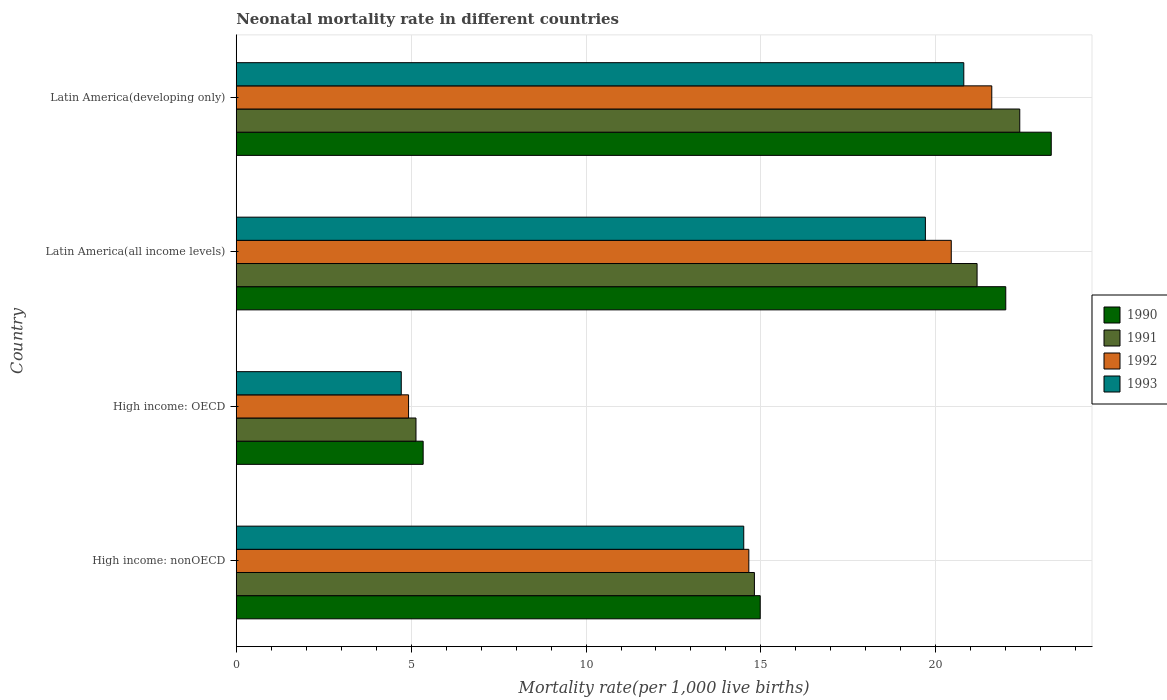How many bars are there on the 4th tick from the top?
Offer a terse response. 4. What is the label of the 3rd group of bars from the top?
Your answer should be compact. High income: OECD. What is the neonatal mortality rate in 1992 in Latin America(developing only)?
Provide a short and direct response. 21.6. Across all countries, what is the maximum neonatal mortality rate in 1992?
Provide a short and direct response. 21.6. Across all countries, what is the minimum neonatal mortality rate in 1992?
Provide a succinct answer. 4.93. In which country was the neonatal mortality rate in 1993 maximum?
Provide a short and direct response. Latin America(developing only). In which country was the neonatal mortality rate in 1991 minimum?
Make the answer very short. High income: OECD. What is the total neonatal mortality rate in 1992 in the graph?
Your answer should be very brief. 61.62. What is the difference between the neonatal mortality rate in 1993 in High income: nonOECD and that in Latin America(developing only)?
Your answer should be compact. -6.29. What is the difference between the neonatal mortality rate in 1992 in Latin America(all income levels) and the neonatal mortality rate in 1990 in Latin America(developing only)?
Offer a terse response. -2.86. What is the average neonatal mortality rate in 1992 per country?
Ensure brevity in your answer.  15.41. What is the difference between the neonatal mortality rate in 1993 and neonatal mortality rate in 1991 in High income: OECD?
Offer a very short reply. -0.42. What is the ratio of the neonatal mortality rate in 1991 in High income: nonOECD to that in Latin America(all income levels)?
Your answer should be compact. 0.7. Is the neonatal mortality rate in 1993 in High income: OECD less than that in High income: nonOECD?
Offer a terse response. Yes. Is the difference between the neonatal mortality rate in 1993 in High income: OECD and Latin America(developing only) greater than the difference between the neonatal mortality rate in 1991 in High income: OECD and Latin America(developing only)?
Provide a short and direct response. Yes. What is the difference between the highest and the second highest neonatal mortality rate in 1990?
Your response must be concise. 1.3. What is the difference between the highest and the lowest neonatal mortality rate in 1990?
Your answer should be compact. 17.96. In how many countries, is the neonatal mortality rate in 1990 greater than the average neonatal mortality rate in 1990 taken over all countries?
Provide a short and direct response. 2. Is the sum of the neonatal mortality rate in 1991 in High income: OECD and High income: nonOECD greater than the maximum neonatal mortality rate in 1992 across all countries?
Keep it short and to the point. No. How many bars are there?
Your response must be concise. 16. Are all the bars in the graph horizontal?
Offer a terse response. Yes. What is the difference between two consecutive major ticks on the X-axis?
Offer a terse response. 5. Are the values on the major ticks of X-axis written in scientific E-notation?
Your answer should be very brief. No. Does the graph contain any zero values?
Your answer should be very brief. No. Does the graph contain grids?
Your answer should be very brief. Yes. How are the legend labels stacked?
Give a very brief answer. Vertical. What is the title of the graph?
Offer a very short reply. Neonatal mortality rate in different countries. What is the label or title of the X-axis?
Provide a succinct answer. Mortality rate(per 1,0 live births). What is the Mortality rate(per 1,000 live births) of 1990 in High income: nonOECD?
Make the answer very short. 14.98. What is the Mortality rate(per 1,000 live births) in 1991 in High income: nonOECD?
Provide a short and direct response. 14.81. What is the Mortality rate(per 1,000 live births) in 1992 in High income: nonOECD?
Make the answer very short. 14.65. What is the Mortality rate(per 1,000 live births) in 1993 in High income: nonOECD?
Offer a terse response. 14.51. What is the Mortality rate(per 1,000 live births) in 1990 in High income: OECD?
Provide a succinct answer. 5.34. What is the Mortality rate(per 1,000 live births) of 1991 in High income: OECD?
Your answer should be compact. 5.14. What is the Mortality rate(per 1,000 live births) of 1992 in High income: OECD?
Your response must be concise. 4.93. What is the Mortality rate(per 1,000 live births) in 1993 in High income: OECD?
Make the answer very short. 4.72. What is the Mortality rate(per 1,000 live births) in 1990 in Latin America(all income levels)?
Make the answer very short. 22. What is the Mortality rate(per 1,000 live births) in 1991 in Latin America(all income levels)?
Offer a very short reply. 21.18. What is the Mortality rate(per 1,000 live births) of 1992 in Latin America(all income levels)?
Keep it short and to the point. 20.44. What is the Mortality rate(per 1,000 live births) in 1993 in Latin America(all income levels)?
Your answer should be compact. 19.7. What is the Mortality rate(per 1,000 live births) of 1990 in Latin America(developing only)?
Provide a succinct answer. 23.3. What is the Mortality rate(per 1,000 live births) in 1991 in Latin America(developing only)?
Your answer should be very brief. 22.4. What is the Mortality rate(per 1,000 live births) in 1992 in Latin America(developing only)?
Provide a succinct answer. 21.6. What is the Mortality rate(per 1,000 live births) of 1993 in Latin America(developing only)?
Provide a succinct answer. 20.8. Across all countries, what is the maximum Mortality rate(per 1,000 live births) of 1990?
Ensure brevity in your answer.  23.3. Across all countries, what is the maximum Mortality rate(per 1,000 live births) of 1991?
Your answer should be very brief. 22.4. Across all countries, what is the maximum Mortality rate(per 1,000 live births) in 1992?
Your response must be concise. 21.6. Across all countries, what is the maximum Mortality rate(per 1,000 live births) in 1993?
Provide a succinct answer. 20.8. Across all countries, what is the minimum Mortality rate(per 1,000 live births) in 1990?
Offer a very short reply. 5.34. Across all countries, what is the minimum Mortality rate(per 1,000 live births) of 1991?
Offer a very short reply. 5.14. Across all countries, what is the minimum Mortality rate(per 1,000 live births) in 1992?
Offer a very short reply. 4.93. Across all countries, what is the minimum Mortality rate(per 1,000 live births) in 1993?
Keep it short and to the point. 4.72. What is the total Mortality rate(per 1,000 live births) in 1990 in the graph?
Make the answer very short. 65.62. What is the total Mortality rate(per 1,000 live births) in 1991 in the graph?
Make the answer very short. 63.53. What is the total Mortality rate(per 1,000 live births) in 1992 in the graph?
Offer a very short reply. 61.62. What is the total Mortality rate(per 1,000 live births) of 1993 in the graph?
Your answer should be compact. 59.73. What is the difference between the Mortality rate(per 1,000 live births) of 1990 in High income: nonOECD and that in High income: OECD?
Your response must be concise. 9.64. What is the difference between the Mortality rate(per 1,000 live births) in 1991 in High income: nonOECD and that in High income: OECD?
Ensure brevity in your answer.  9.68. What is the difference between the Mortality rate(per 1,000 live births) of 1992 in High income: nonOECD and that in High income: OECD?
Give a very brief answer. 9.73. What is the difference between the Mortality rate(per 1,000 live births) of 1993 in High income: nonOECD and that in High income: OECD?
Make the answer very short. 9.79. What is the difference between the Mortality rate(per 1,000 live births) in 1990 in High income: nonOECD and that in Latin America(all income levels)?
Provide a succinct answer. -7.02. What is the difference between the Mortality rate(per 1,000 live births) in 1991 in High income: nonOECD and that in Latin America(all income levels)?
Make the answer very short. -6.37. What is the difference between the Mortality rate(per 1,000 live births) of 1992 in High income: nonOECD and that in Latin America(all income levels)?
Make the answer very short. -5.79. What is the difference between the Mortality rate(per 1,000 live births) in 1993 in High income: nonOECD and that in Latin America(all income levels)?
Offer a very short reply. -5.19. What is the difference between the Mortality rate(per 1,000 live births) in 1990 in High income: nonOECD and that in Latin America(developing only)?
Your answer should be compact. -8.32. What is the difference between the Mortality rate(per 1,000 live births) of 1991 in High income: nonOECD and that in Latin America(developing only)?
Make the answer very short. -7.59. What is the difference between the Mortality rate(per 1,000 live births) of 1992 in High income: nonOECD and that in Latin America(developing only)?
Offer a terse response. -6.95. What is the difference between the Mortality rate(per 1,000 live births) of 1993 in High income: nonOECD and that in Latin America(developing only)?
Your answer should be compact. -6.29. What is the difference between the Mortality rate(per 1,000 live births) of 1990 in High income: OECD and that in Latin America(all income levels)?
Provide a succinct answer. -16.66. What is the difference between the Mortality rate(per 1,000 live births) in 1991 in High income: OECD and that in Latin America(all income levels)?
Provide a short and direct response. -16.04. What is the difference between the Mortality rate(per 1,000 live births) in 1992 in High income: OECD and that in Latin America(all income levels)?
Ensure brevity in your answer.  -15.52. What is the difference between the Mortality rate(per 1,000 live births) of 1993 in High income: OECD and that in Latin America(all income levels)?
Give a very brief answer. -14.98. What is the difference between the Mortality rate(per 1,000 live births) of 1990 in High income: OECD and that in Latin America(developing only)?
Provide a succinct answer. -17.96. What is the difference between the Mortality rate(per 1,000 live births) of 1991 in High income: OECD and that in Latin America(developing only)?
Ensure brevity in your answer.  -17.26. What is the difference between the Mortality rate(per 1,000 live births) of 1992 in High income: OECD and that in Latin America(developing only)?
Ensure brevity in your answer.  -16.67. What is the difference between the Mortality rate(per 1,000 live births) of 1993 in High income: OECD and that in Latin America(developing only)?
Provide a short and direct response. -16.08. What is the difference between the Mortality rate(per 1,000 live births) in 1990 in Latin America(all income levels) and that in Latin America(developing only)?
Provide a succinct answer. -1.3. What is the difference between the Mortality rate(per 1,000 live births) of 1991 in Latin America(all income levels) and that in Latin America(developing only)?
Keep it short and to the point. -1.22. What is the difference between the Mortality rate(per 1,000 live births) of 1992 in Latin America(all income levels) and that in Latin America(developing only)?
Make the answer very short. -1.16. What is the difference between the Mortality rate(per 1,000 live births) of 1993 in Latin America(all income levels) and that in Latin America(developing only)?
Make the answer very short. -1.1. What is the difference between the Mortality rate(per 1,000 live births) of 1990 in High income: nonOECD and the Mortality rate(per 1,000 live births) of 1991 in High income: OECD?
Give a very brief answer. 9.84. What is the difference between the Mortality rate(per 1,000 live births) in 1990 in High income: nonOECD and the Mortality rate(per 1,000 live births) in 1992 in High income: OECD?
Your response must be concise. 10.05. What is the difference between the Mortality rate(per 1,000 live births) in 1990 in High income: nonOECD and the Mortality rate(per 1,000 live births) in 1993 in High income: OECD?
Make the answer very short. 10.26. What is the difference between the Mortality rate(per 1,000 live births) of 1991 in High income: nonOECD and the Mortality rate(per 1,000 live births) of 1992 in High income: OECD?
Provide a short and direct response. 9.89. What is the difference between the Mortality rate(per 1,000 live births) in 1991 in High income: nonOECD and the Mortality rate(per 1,000 live births) in 1993 in High income: OECD?
Provide a succinct answer. 10.1. What is the difference between the Mortality rate(per 1,000 live births) of 1992 in High income: nonOECD and the Mortality rate(per 1,000 live births) of 1993 in High income: OECD?
Your answer should be very brief. 9.94. What is the difference between the Mortality rate(per 1,000 live births) in 1990 in High income: nonOECD and the Mortality rate(per 1,000 live births) in 1991 in Latin America(all income levels)?
Your response must be concise. -6.2. What is the difference between the Mortality rate(per 1,000 live births) of 1990 in High income: nonOECD and the Mortality rate(per 1,000 live births) of 1992 in Latin America(all income levels)?
Make the answer very short. -5.46. What is the difference between the Mortality rate(per 1,000 live births) in 1990 in High income: nonOECD and the Mortality rate(per 1,000 live births) in 1993 in Latin America(all income levels)?
Offer a very short reply. -4.72. What is the difference between the Mortality rate(per 1,000 live births) of 1991 in High income: nonOECD and the Mortality rate(per 1,000 live births) of 1992 in Latin America(all income levels)?
Your answer should be very brief. -5.63. What is the difference between the Mortality rate(per 1,000 live births) in 1991 in High income: nonOECD and the Mortality rate(per 1,000 live births) in 1993 in Latin America(all income levels)?
Your answer should be very brief. -4.89. What is the difference between the Mortality rate(per 1,000 live births) in 1992 in High income: nonOECD and the Mortality rate(per 1,000 live births) in 1993 in Latin America(all income levels)?
Offer a terse response. -5.05. What is the difference between the Mortality rate(per 1,000 live births) in 1990 in High income: nonOECD and the Mortality rate(per 1,000 live births) in 1991 in Latin America(developing only)?
Ensure brevity in your answer.  -7.42. What is the difference between the Mortality rate(per 1,000 live births) in 1990 in High income: nonOECD and the Mortality rate(per 1,000 live births) in 1992 in Latin America(developing only)?
Your answer should be compact. -6.62. What is the difference between the Mortality rate(per 1,000 live births) in 1990 in High income: nonOECD and the Mortality rate(per 1,000 live births) in 1993 in Latin America(developing only)?
Provide a succinct answer. -5.82. What is the difference between the Mortality rate(per 1,000 live births) of 1991 in High income: nonOECD and the Mortality rate(per 1,000 live births) of 1992 in Latin America(developing only)?
Ensure brevity in your answer.  -6.79. What is the difference between the Mortality rate(per 1,000 live births) of 1991 in High income: nonOECD and the Mortality rate(per 1,000 live births) of 1993 in Latin America(developing only)?
Ensure brevity in your answer.  -5.99. What is the difference between the Mortality rate(per 1,000 live births) in 1992 in High income: nonOECD and the Mortality rate(per 1,000 live births) in 1993 in Latin America(developing only)?
Ensure brevity in your answer.  -6.15. What is the difference between the Mortality rate(per 1,000 live births) of 1990 in High income: OECD and the Mortality rate(per 1,000 live births) of 1991 in Latin America(all income levels)?
Ensure brevity in your answer.  -15.84. What is the difference between the Mortality rate(per 1,000 live births) in 1990 in High income: OECD and the Mortality rate(per 1,000 live births) in 1992 in Latin America(all income levels)?
Ensure brevity in your answer.  -15.1. What is the difference between the Mortality rate(per 1,000 live births) in 1990 in High income: OECD and the Mortality rate(per 1,000 live births) in 1993 in Latin America(all income levels)?
Give a very brief answer. -14.36. What is the difference between the Mortality rate(per 1,000 live births) of 1991 in High income: OECD and the Mortality rate(per 1,000 live births) of 1992 in Latin America(all income levels)?
Your answer should be compact. -15.3. What is the difference between the Mortality rate(per 1,000 live births) in 1991 in High income: OECD and the Mortality rate(per 1,000 live births) in 1993 in Latin America(all income levels)?
Provide a succinct answer. -14.56. What is the difference between the Mortality rate(per 1,000 live births) in 1992 in High income: OECD and the Mortality rate(per 1,000 live births) in 1993 in Latin America(all income levels)?
Your response must be concise. -14.78. What is the difference between the Mortality rate(per 1,000 live births) in 1990 in High income: OECD and the Mortality rate(per 1,000 live births) in 1991 in Latin America(developing only)?
Your response must be concise. -17.06. What is the difference between the Mortality rate(per 1,000 live births) of 1990 in High income: OECD and the Mortality rate(per 1,000 live births) of 1992 in Latin America(developing only)?
Make the answer very short. -16.26. What is the difference between the Mortality rate(per 1,000 live births) of 1990 in High income: OECD and the Mortality rate(per 1,000 live births) of 1993 in Latin America(developing only)?
Your response must be concise. -15.46. What is the difference between the Mortality rate(per 1,000 live births) in 1991 in High income: OECD and the Mortality rate(per 1,000 live births) in 1992 in Latin America(developing only)?
Give a very brief answer. -16.46. What is the difference between the Mortality rate(per 1,000 live births) in 1991 in High income: OECD and the Mortality rate(per 1,000 live births) in 1993 in Latin America(developing only)?
Make the answer very short. -15.66. What is the difference between the Mortality rate(per 1,000 live births) of 1992 in High income: OECD and the Mortality rate(per 1,000 live births) of 1993 in Latin America(developing only)?
Your response must be concise. -15.87. What is the difference between the Mortality rate(per 1,000 live births) in 1990 in Latin America(all income levels) and the Mortality rate(per 1,000 live births) in 1991 in Latin America(developing only)?
Ensure brevity in your answer.  -0.4. What is the difference between the Mortality rate(per 1,000 live births) in 1990 in Latin America(all income levels) and the Mortality rate(per 1,000 live births) in 1992 in Latin America(developing only)?
Ensure brevity in your answer.  0.4. What is the difference between the Mortality rate(per 1,000 live births) of 1990 in Latin America(all income levels) and the Mortality rate(per 1,000 live births) of 1993 in Latin America(developing only)?
Your response must be concise. 1.2. What is the difference between the Mortality rate(per 1,000 live births) of 1991 in Latin America(all income levels) and the Mortality rate(per 1,000 live births) of 1992 in Latin America(developing only)?
Provide a short and direct response. -0.42. What is the difference between the Mortality rate(per 1,000 live births) in 1991 in Latin America(all income levels) and the Mortality rate(per 1,000 live births) in 1993 in Latin America(developing only)?
Offer a very short reply. 0.38. What is the difference between the Mortality rate(per 1,000 live births) in 1992 in Latin America(all income levels) and the Mortality rate(per 1,000 live births) in 1993 in Latin America(developing only)?
Your answer should be very brief. -0.36. What is the average Mortality rate(per 1,000 live births) in 1990 per country?
Provide a short and direct response. 16.41. What is the average Mortality rate(per 1,000 live births) of 1991 per country?
Offer a very short reply. 15.88. What is the average Mortality rate(per 1,000 live births) in 1992 per country?
Offer a very short reply. 15.41. What is the average Mortality rate(per 1,000 live births) of 1993 per country?
Give a very brief answer. 14.93. What is the difference between the Mortality rate(per 1,000 live births) in 1990 and Mortality rate(per 1,000 live births) in 1991 in High income: nonOECD?
Ensure brevity in your answer.  0.17. What is the difference between the Mortality rate(per 1,000 live births) in 1990 and Mortality rate(per 1,000 live births) in 1992 in High income: nonOECD?
Your answer should be very brief. 0.33. What is the difference between the Mortality rate(per 1,000 live births) in 1990 and Mortality rate(per 1,000 live births) in 1993 in High income: nonOECD?
Provide a short and direct response. 0.47. What is the difference between the Mortality rate(per 1,000 live births) in 1991 and Mortality rate(per 1,000 live births) in 1992 in High income: nonOECD?
Give a very brief answer. 0.16. What is the difference between the Mortality rate(per 1,000 live births) in 1991 and Mortality rate(per 1,000 live births) in 1993 in High income: nonOECD?
Offer a terse response. 0.3. What is the difference between the Mortality rate(per 1,000 live births) in 1992 and Mortality rate(per 1,000 live births) in 1993 in High income: nonOECD?
Provide a short and direct response. 0.15. What is the difference between the Mortality rate(per 1,000 live births) of 1990 and Mortality rate(per 1,000 live births) of 1991 in High income: OECD?
Give a very brief answer. 0.21. What is the difference between the Mortality rate(per 1,000 live births) in 1990 and Mortality rate(per 1,000 live births) in 1992 in High income: OECD?
Your response must be concise. 0.42. What is the difference between the Mortality rate(per 1,000 live births) of 1990 and Mortality rate(per 1,000 live births) of 1993 in High income: OECD?
Give a very brief answer. 0.63. What is the difference between the Mortality rate(per 1,000 live births) in 1991 and Mortality rate(per 1,000 live births) in 1992 in High income: OECD?
Offer a very short reply. 0.21. What is the difference between the Mortality rate(per 1,000 live births) of 1991 and Mortality rate(per 1,000 live births) of 1993 in High income: OECD?
Ensure brevity in your answer.  0.42. What is the difference between the Mortality rate(per 1,000 live births) in 1992 and Mortality rate(per 1,000 live births) in 1993 in High income: OECD?
Keep it short and to the point. 0.21. What is the difference between the Mortality rate(per 1,000 live births) of 1990 and Mortality rate(per 1,000 live births) of 1991 in Latin America(all income levels)?
Ensure brevity in your answer.  0.82. What is the difference between the Mortality rate(per 1,000 live births) of 1990 and Mortality rate(per 1,000 live births) of 1992 in Latin America(all income levels)?
Provide a succinct answer. 1.56. What is the difference between the Mortality rate(per 1,000 live births) of 1990 and Mortality rate(per 1,000 live births) of 1993 in Latin America(all income levels)?
Make the answer very short. 2.3. What is the difference between the Mortality rate(per 1,000 live births) of 1991 and Mortality rate(per 1,000 live births) of 1992 in Latin America(all income levels)?
Provide a succinct answer. 0.74. What is the difference between the Mortality rate(per 1,000 live births) of 1991 and Mortality rate(per 1,000 live births) of 1993 in Latin America(all income levels)?
Provide a short and direct response. 1.48. What is the difference between the Mortality rate(per 1,000 live births) of 1992 and Mortality rate(per 1,000 live births) of 1993 in Latin America(all income levels)?
Offer a terse response. 0.74. What is the difference between the Mortality rate(per 1,000 live births) in 1990 and Mortality rate(per 1,000 live births) in 1992 in Latin America(developing only)?
Keep it short and to the point. 1.7. What is the difference between the Mortality rate(per 1,000 live births) of 1992 and Mortality rate(per 1,000 live births) of 1993 in Latin America(developing only)?
Offer a very short reply. 0.8. What is the ratio of the Mortality rate(per 1,000 live births) in 1990 in High income: nonOECD to that in High income: OECD?
Ensure brevity in your answer.  2.8. What is the ratio of the Mortality rate(per 1,000 live births) of 1991 in High income: nonOECD to that in High income: OECD?
Make the answer very short. 2.88. What is the ratio of the Mortality rate(per 1,000 live births) of 1992 in High income: nonOECD to that in High income: OECD?
Your answer should be compact. 2.97. What is the ratio of the Mortality rate(per 1,000 live births) in 1993 in High income: nonOECD to that in High income: OECD?
Provide a short and direct response. 3.08. What is the ratio of the Mortality rate(per 1,000 live births) in 1990 in High income: nonOECD to that in Latin America(all income levels)?
Offer a very short reply. 0.68. What is the ratio of the Mortality rate(per 1,000 live births) of 1991 in High income: nonOECD to that in Latin America(all income levels)?
Your answer should be compact. 0.7. What is the ratio of the Mortality rate(per 1,000 live births) of 1992 in High income: nonOECD to that in Latin America(all income levels)?
Offer a very short reply. 0.72. What is the ratio of the Mortality rate(per 1,000 live births) of 1993 in High income: nonOECD to that in Latin America(all income levels)?
Provide a succinct answer. 0.74. What is the ratio of the Mortality rate(per 1,000 live births) in 1990 in High income: nonOECD to that in Latin America(developing only)?
Give a very brief answer. 0.64. What is the ratio of the Mortality rate(per 1,000 live births) of 1991 in High income: nonOECD to that in Latin America(developing only)?
Provide a short and direct response. 0.66. What is the ratio of the Mortality rate(per 1,000 live births) of 1992 in High income: nonOECD to that in Latin America(developing only)?
Ensure brevity in your answer.  0.68. What is the ratio of the Mortality rate(per 1,000 live births) of 1993 in High income: nonOECD to that in Latin America(developing only)?
Offer a very short reply. 0.7. What is the ratio of the Mortality rate(per 1,000 live births) of 1990 in High income: OECD to that in Latin America(all income levels)?
Your answer should be compact. 0.24. What is the ratio of the Mortality rate(per 1,000 live births) in 1991 in High income: OECD to that in Latin America(all income levels)?
Provide a succinct answer. 0.24. What is the ratio of the Mortality rate(per 1,000 live births) in 1992 in High income: OECD to that in Latin America(all income levels)?
Your answer should be very brief. 0.24. What is the ratio of the Mortality rate(per 1,000 live births) in 1993 in High income: OECD to that in Latin America(all income levels)?
Ensure brevity in your answer.  0.24. What is the ratio of the Mortality rate(per 1,000 live births) of 1990 in High income: OECD to that in Latin America(developing only)?
Give a very brief answer. 0.23. What is the ratio of the Mortality rate(per 1,000 live births) of 1991 in High income: OECD to that in Latin America(developing only)?
Provide a succinct answer. 0.23. What is the ratio of the Mortality rate(per 1,000 live births) in 1992 in High income: OECD to that in Latin America(developing only)?
Provide a succinct answer. 0.23. What is the ratio of the Mortality rate(per 1,000 live births) of 1993 in High income: OECD to that in Latin America(developing only)?
Offer a terse response. 0.23. What is the ratio of the Mortality rate(per 1,000 live births) of 1990 in Latin America(all income levels) to that in Latin America(developing only)?
Offer a very short reply. 0.94. What is the ratio of the Mortality rate(per 1,000 live births) in 1991 in Latin America(all income levels) to that in Latin America(developing only)?
Offer a very short reply. 0.95. What is the ratio of the Mortality rate(per 1,000 live births) in 1992 in Latin America(all income levels) to that in Latin America(developing only)?
Keep it short and to the point. 0.95. What is the ratio of the Mortality rate(per 1,000 live births) of 1993 in Latin America(all income levels) to that in Latin America(developing only)?
Give a very brief answer. 0.95. What is the difference between the highest and the second highest Mortality rate(per 1,000 live births) in 1990?
Offer a terse response. 1.3. What is the difference between the highest and the second highest Mortality rate(per 1,000 live births) in 1991?
Provide a short and direct response. 1.22. What is the difference between the highest and the second highest Mortality rate(per 1,000 live births) of 1992?
Ensure brevity in your answer.  1.16. What is the difference between the highest and the second highest Mortality rate(per 1,000 live births) in 1993?
Your answer should be very brief. 1.1. What is the difference between the highest and the lowest Mortality rate(per 1,000 live births) of 1990?
Provide a short and direct response. 17.96. What is the difference between the highest and the lowest Mortality rate(per 1,000 live births) of 1991?
Your answer should be compact. 17.26. What is the difference between the highest and the lowest Mortality rate(per 1,000 live births) in 1992?
Your response must be concise. 16.67. What is the difference between the highest and the lowest Mortality rate(per 1,000 live births) of 1993?
Provide a succinct answer. 16.08. 